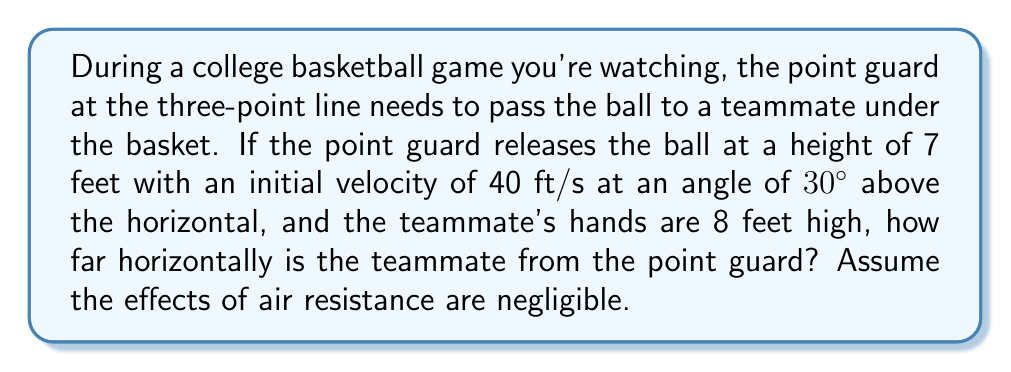Provide a solution to this math problem. Let's approach this step-by-step using projectile motion equations:

1) First, we need to identify our known variables:
   - Initial height (h₀) = 7 ft
   - Final height (h) = 8 ft
   - Initial velocity (v₀) = 40 ft/s
   - Angle (θ) = 30°
   - Acceleration due to gravity (g) = 32 ft/s²

2) We'll use the following equations:
   $$x = v₀cosθ * t$$
   $$y = h₀ + v₀sinθ * t - \frac{1}{2}gt²$$

3) In this case, we know the final y position (8 ft). Let's substitute this into the y equation:
   $$8 = 7 + 40sin30° * t - 16t²$$

4) Simplify:
   $$1 = 20t - 16t²$$
   $$16t² - 20t + 1 = 0$$

5) This is a quadratic equation. We can solve it using the quadratic formula:
   $$t = \frac{-b ± \sqrt{b² - 4ac}}{2a}$$
   Where a = 16, b = -20, and c = 1

6) Solving this:
   $$t = \frac{20 ± \sqrt{400 - 64}}{32} = \frac{20 ± \sqrt{336}}{32}$$
   $$t ≈ 1.07 \text{ or } 0.18$$

7) We take the larger value as it represents the time when the ball reaches the teammate's hands.

8) Now we can use this time in the x equation:
   $$x = 40cos30° * 1.07$$
   $$x ≈ 37.1 \text{ ft}$$

Thus, the teammate is approximately 37.1 feet horizontally from the point guard.
Answer: 37.1 ft 